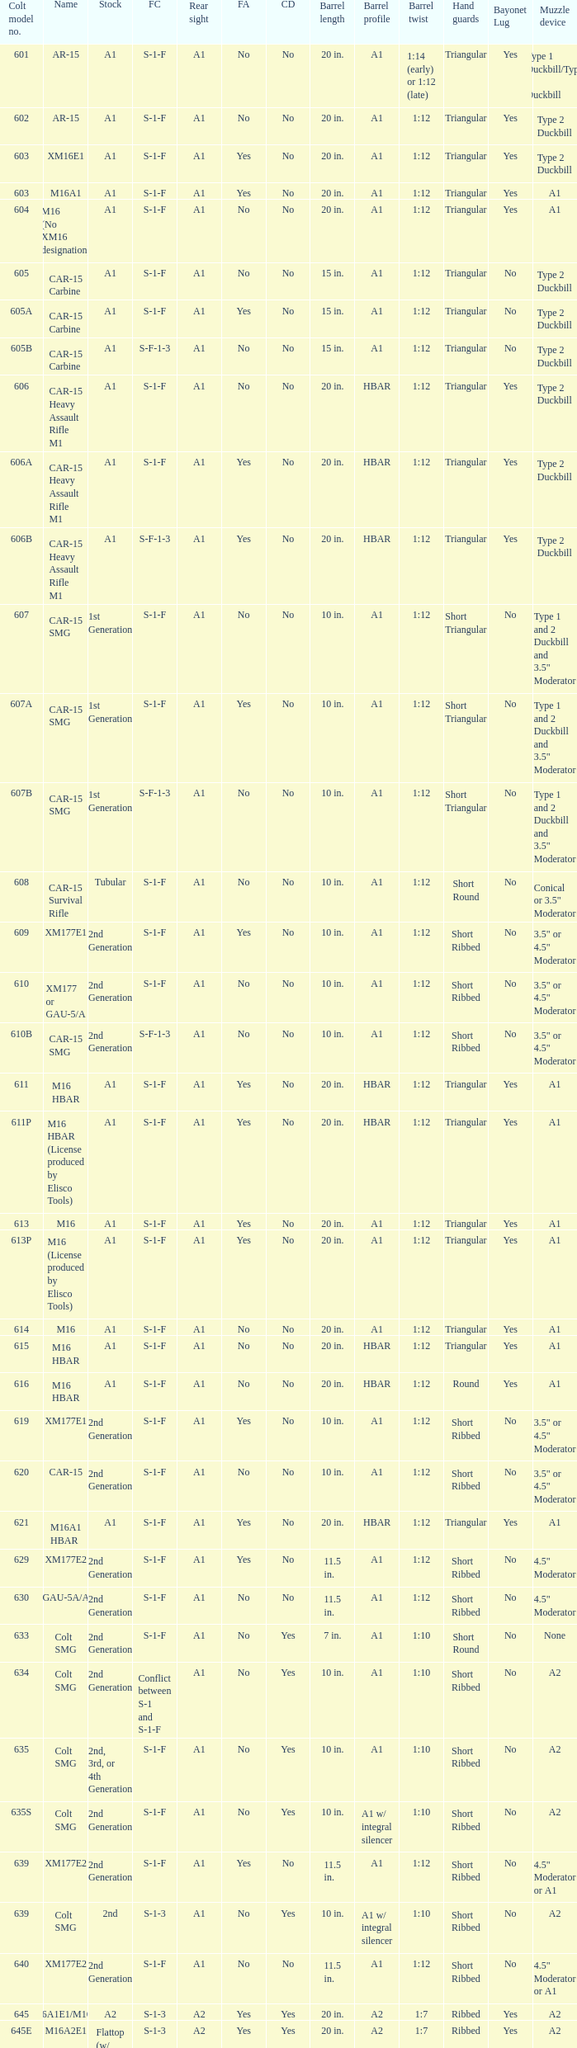What are the Colt model numbers of the models named GAU-5A/A, with no bayonet lug, no case deflector and stock of 2nd generation?  630, 649. 